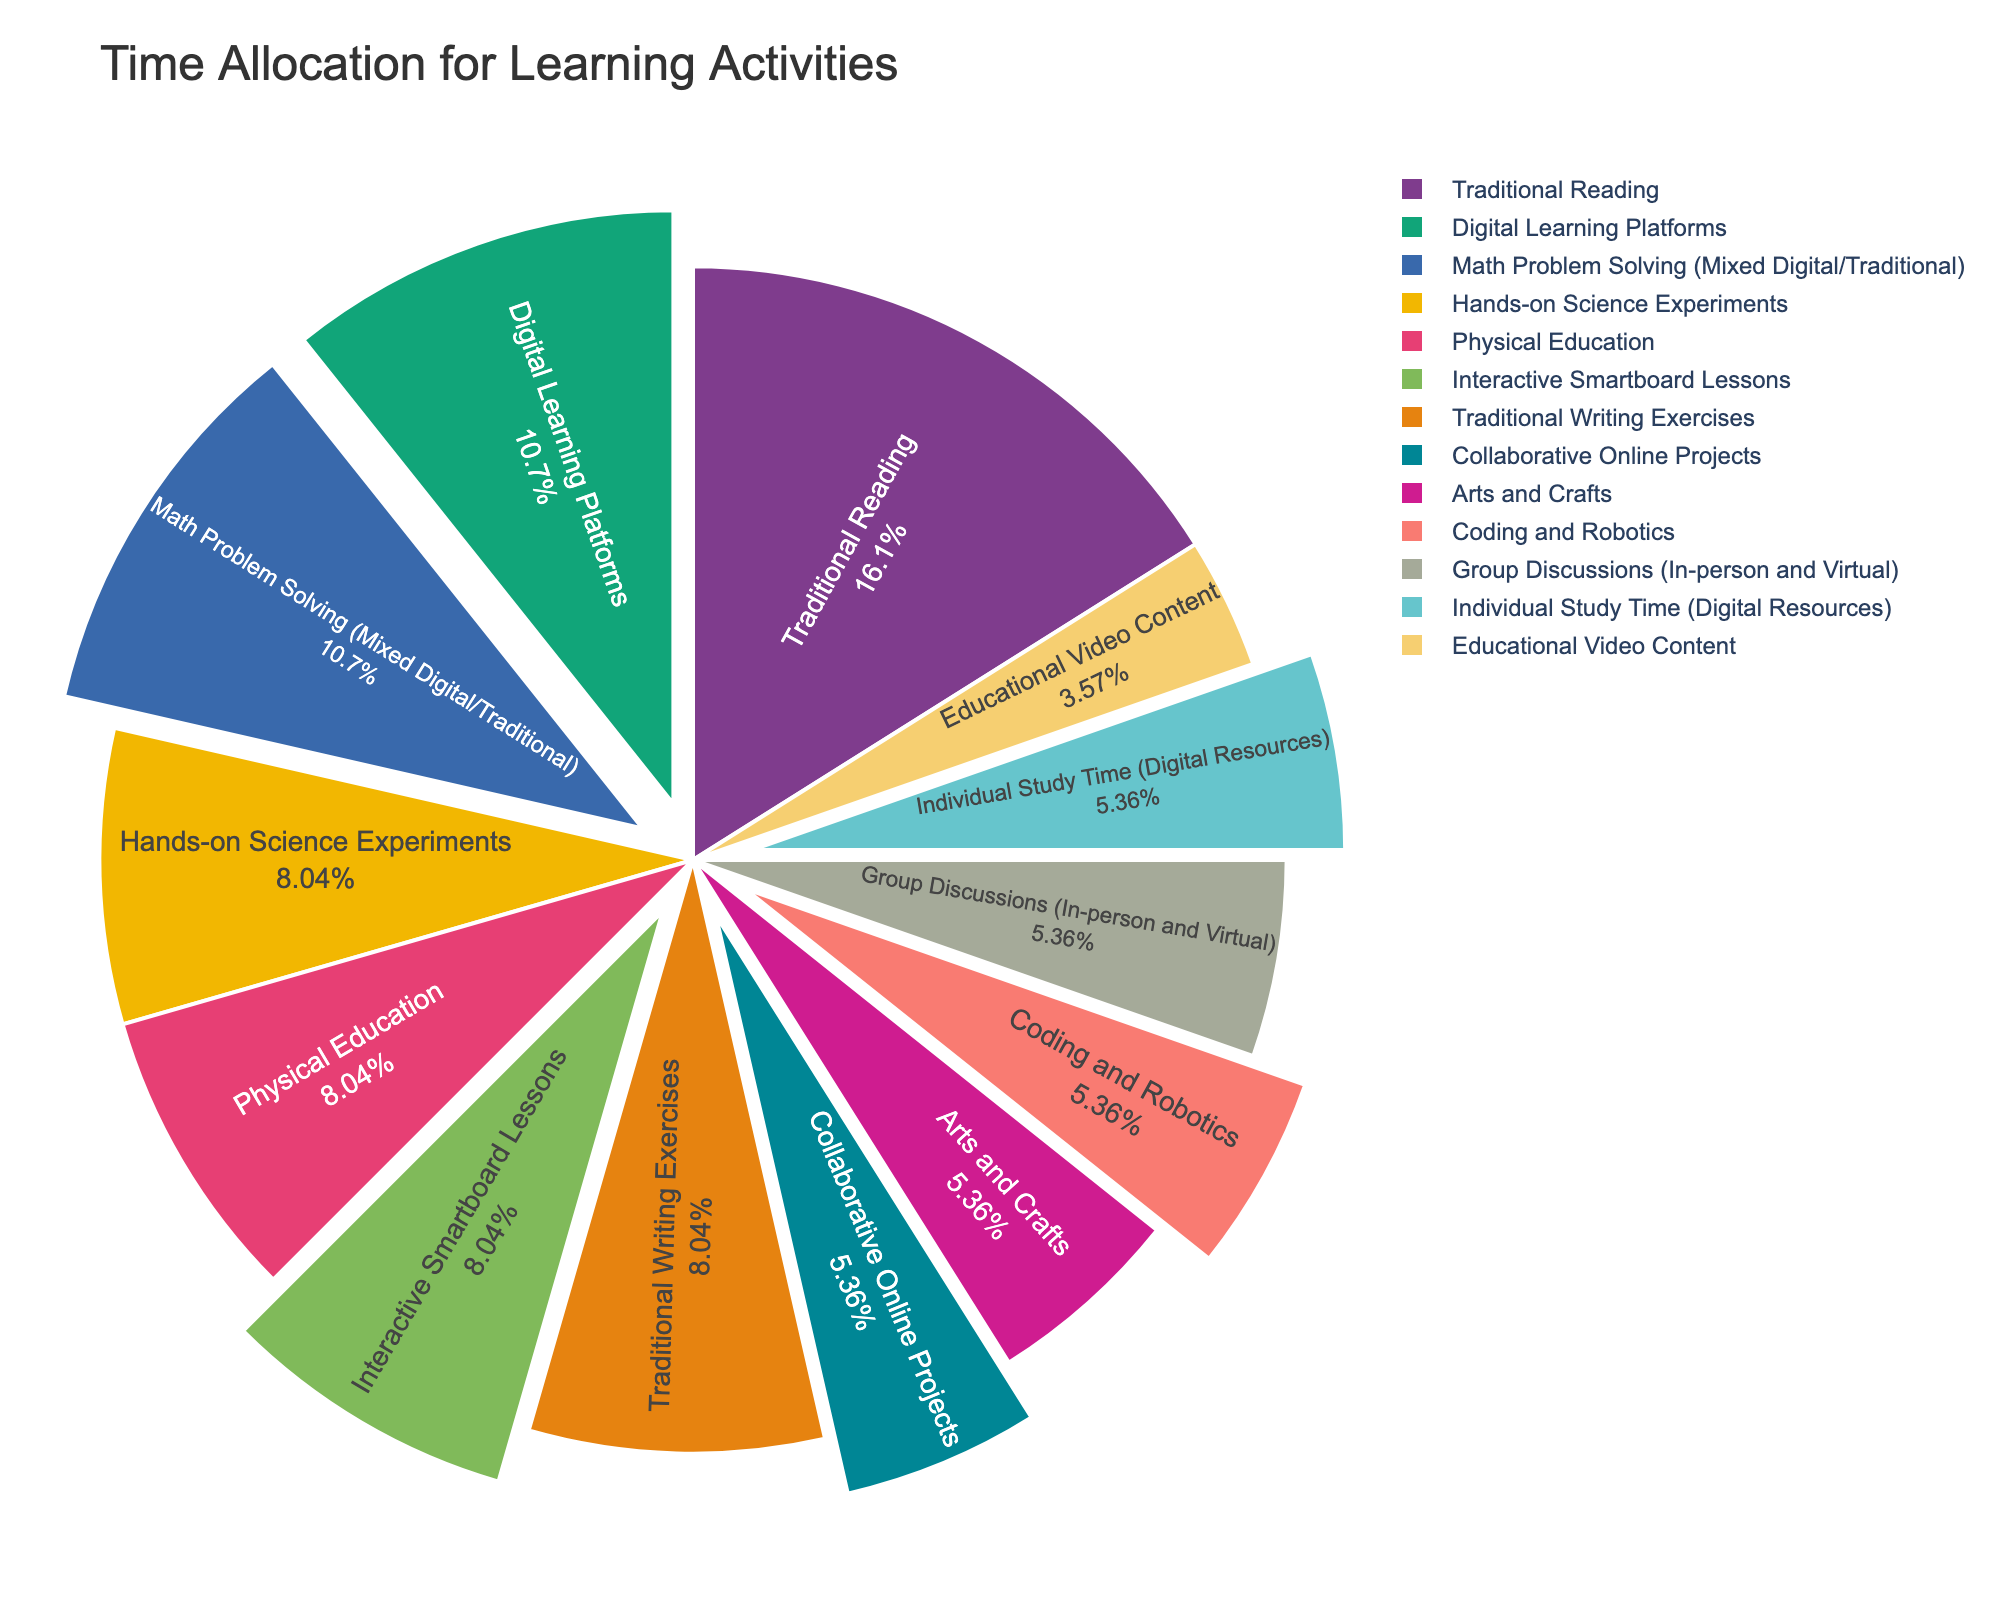Which activity takes up the most time in the school day? The activity taking up the most time can be identified by finding the largest slice in the pie chart. Traditional Reading is the largest segment.
Answer: Traditional Reading How much total time is spent on physical activities? Locate the slices corresponding to Physical Education and sum their values. Physical Education is 45 minutes.
Answer: 45 minutes Is more time spent on Digital Learning Platforms or Traditional Writing Exercises? Compare the sizes of the slices for Digital Learning Platforms and Traditional Writing Exercises. Digital Learning Platforms have a larger slice.
Answer: Digital Learning Platforms What is the combined percentage of time spent on arts-related activities compared to science-related activities? Arts-related activities include Arts and Crafts (30 minutes), and science-related activities include Hands-on Science Experiments (45 minutes). The combined percentage is (30/550)*100% for Arts and Crafts and (45/550)*100% for Hands-on Science Experiments.
Answer: 5.45% for Arts and Crafts and 8.18% for Hands-on Science Experiments Are there any activities that use both digital and traditional methods? If so, what are they? Locate slices that are described as mixed or hybrid methods in their labels. Math Problem Solving (Mixed Digital/Traditional) and Group Discussions (In-person and Virtual) are the activities.
Answer: Math Problem Solving and Group Discussions What percentage of the school day is dedicated to coding and robotics? Identify the slice labeled Coding and Robotics and note the percentage value given.
Answer: 5.45% Is the time allocated to Digital Learning Platforms more or less than the time allocated to Individual Study Time (Digital Resources)? Compare the sizes of the slices for Digital Learning Platforms (60 minutes) and Individual Study Time (Digital Resources) (30 minutes).
Answer: More What visual cues indicate the use of digital tools in activities? Identify the slices with a slight pull effect; these are visually pulled out from the pie to emphasize digital tool inclusion.
Answer: Slight pull effect What is the ratio of time spent on Traditional Reading to Interactive Smartboard Lessons? Find the slices for Traditional Reading (90 minutes) and Interactive Smartboard Lessons (45 minutes) and calculate the ratio 90/45.
Answer: 2:1 Which activities are shorter than 30 minutes? Identify slices representing activities with less than 30 minutes. The only activity is Educational Video Content.
Answer: Educational Video Content 